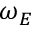<formula> <loc_0><loc_0><loc_500><loc_500>\omega _ { E }</formula> 